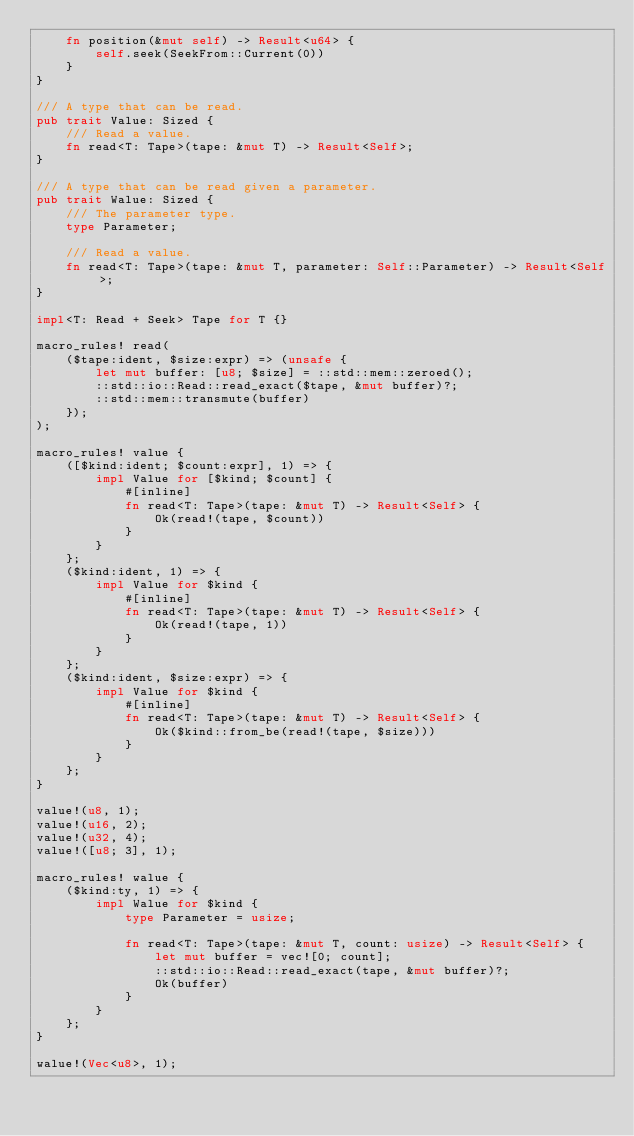<code> <loc_0><loc_0><loc_500><loc_500><_Rust_>    fn position(&mut self) -> Result<u64> {
        self.seek(SeekFrom::Current(0))
    }
}

/// A type that can be read.
pub trait Value: Sized {
    /// Read a value.
    fn read<T: Tape>(tape: &mut T) -> Result<Self>;
}

/// A type that can be read given a parameter.
pub trait Walue: Sized {
    /// The parameter type.
    type Parameter;

    /// Read a value.
    fn read<T: Tape>(tape: &mut T, parameter: Self::Parameter) -> Result<Self>;
}

impl<T: Read + Seek> Tape for T {}

macro_rules! read(
    ($tape:ident, $size:expr) => (unsafe {
        let mut buffer: [u8; $size] = ::std::mem::zeroed();
        ::std::io::Read::read_exact($tape, &mut buffer)?;
        ::std::mem::transmute(buffer)
    });
);

macro_rules! value {
    ([$kind:ident; $count:expr], 1) => {
        impl Value for [$kind; $count] {
            #[inline]
            fn read<T: Tape>(tape: &mut T) -> Result<Self> {
                Ok(read!(tape, $count))
            }
        }
    };
    ($kind:ident, 1) => {
        impl Value for $kind {
            #[inline]
            fn read<T: Tape>(tape: &mut T) -> Result<Self> {
                Ok(read!(tape, 1))
            }
        }
    };
    ($kind:ident, $size:expr) => {
        impl Value for $kind {
            #[inline]
            fn read<T: Tape>(tape: &mut T) -> Result<Self> {
                Ok($kind::from_be(read!(tape, $size)))
            }
        }
    };
}

value!(u8, 1);
value!(u16, 2);
value!(u32, 4);
value!([u8; 3], 1);

macro_rules! walue {
    ($kind:ty, 1) => {
        impl Walue for $kind {
            type Parameter = usize;

            fn read<T: Tape>(tape: &mut T, count: usize) -> Result<Self> {
                let mut buffer = vec![0; count];
                ::std::io::Read::read_exact(tape, &mut buffer)?;
                Ok(buffer)
            }
        }
    };
}

walue!(Vec<u8>, 1);
</code> 